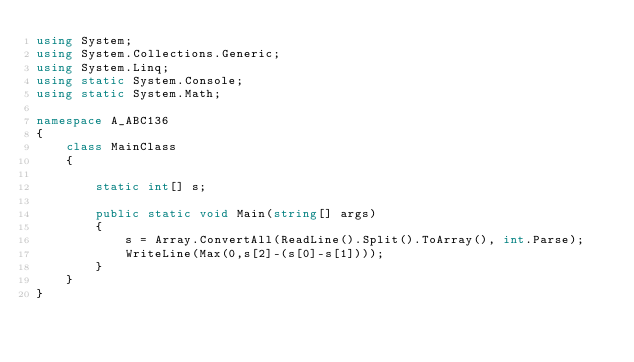<code> <loc_0><loc_0><loc_500><loc_500><_C#_>using System;
using System.Collections.Generic;
using System.Linq;
using static System.Console;
using static System.Math;

namespace A_ABC136
{
    class MainClass
    {

        static int[] s;

        public static void Main(string[] args)
        {
            s = Array.ConvertAll(ReadLine().Split().ToArray(), int.Parse);
            WriteLine(Max(0,s[2]-(s[0]-s[1])));
        }
    }
}
</code> 